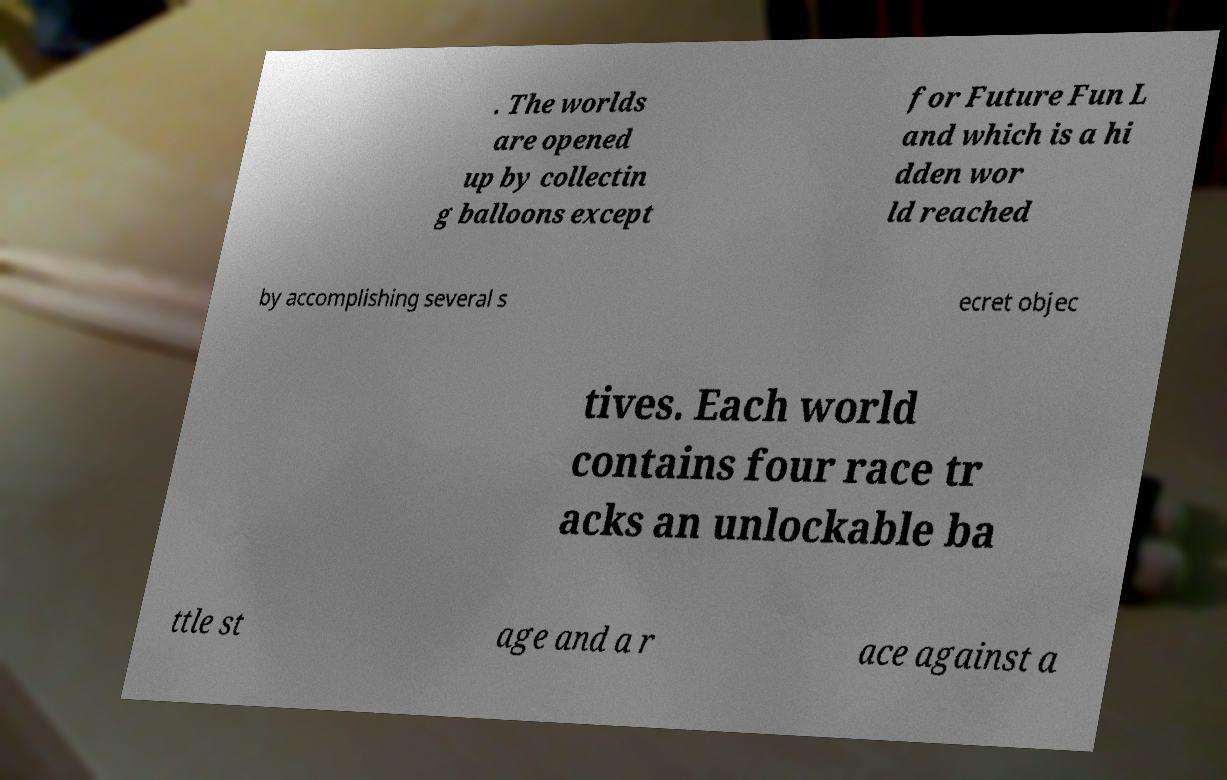Please read and relay the text visible in this image. What does it say? . The worlds are opened up by collectin g balloons except for Future Fun L and which is a hi dden wor ld reached by accomplishing several s ecret objec tives. Each world contains four race tr acks an unlockable ba ttle st age and a r ace against a 